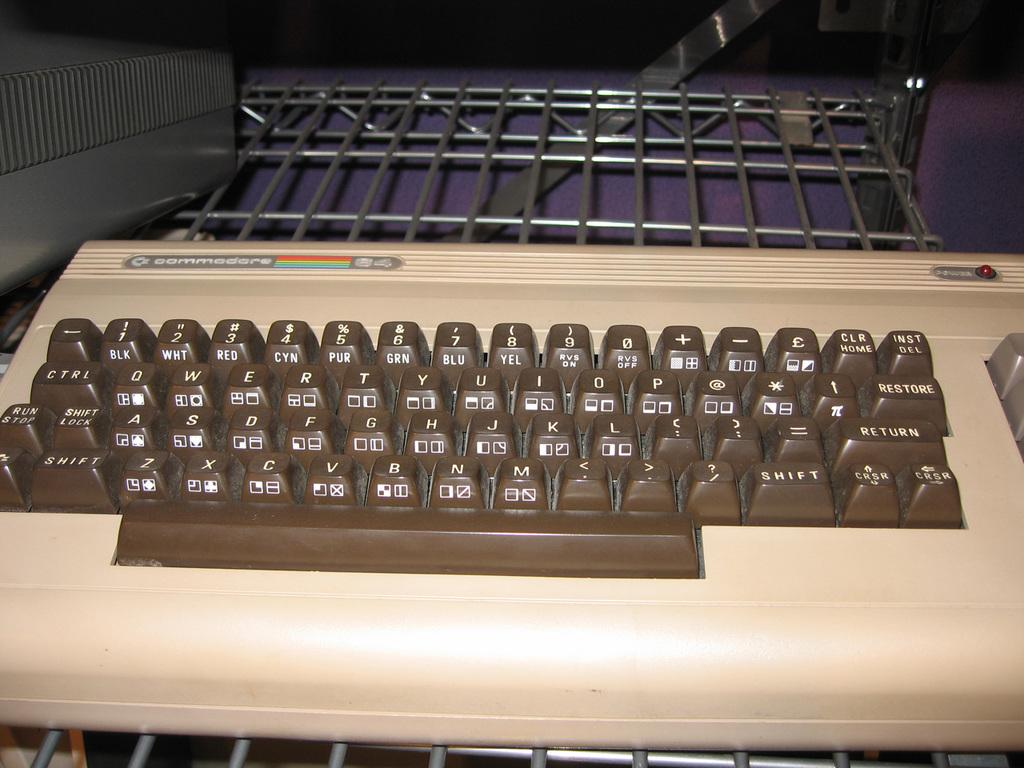Provide a one-sentence caption for the provided image. An old brown and beige keyboard from the Commodore 64. 